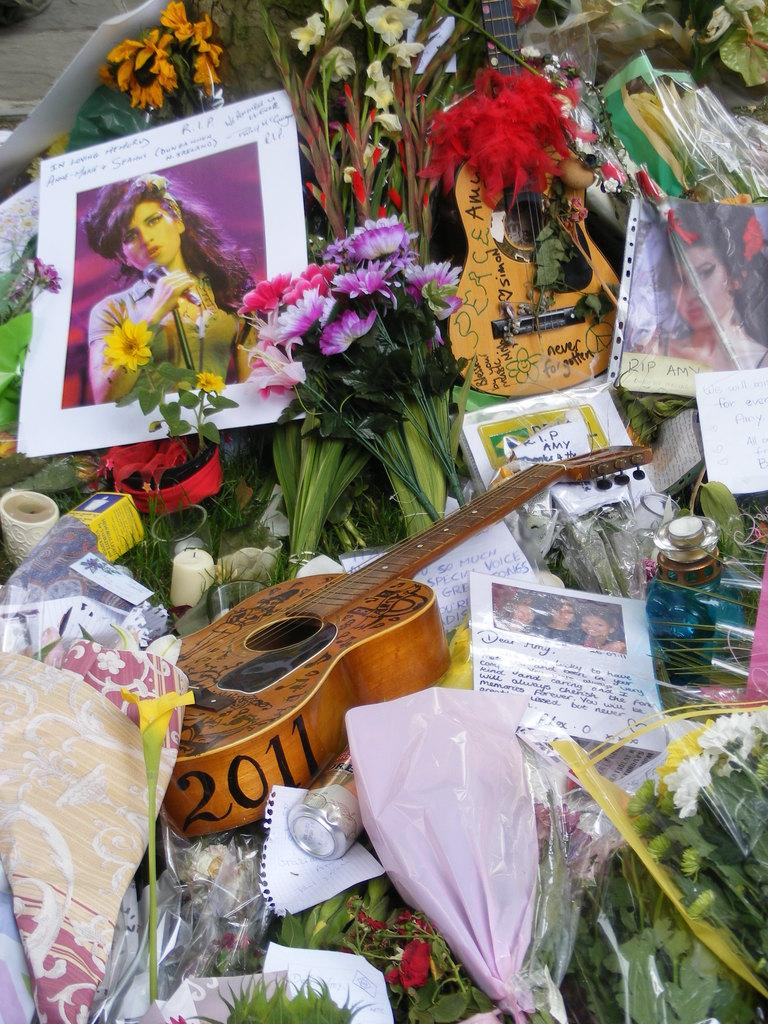What type of living organisms can be seen in the image? The image contains flowers. What type of musical instruments can be seen in the image? The image contains guitars. What type of personal or historical items can be seen in the image? The image contains photos. What type of written or drawn items can be seen in the image? The image contains papers. What type of decorative items can be seen in the image? The image contains decorative items. Can you see any caves in the image? There is no cave present in the image. What type of square-shaped object can be seen in the image? There is no square-shaped object present in the image. 